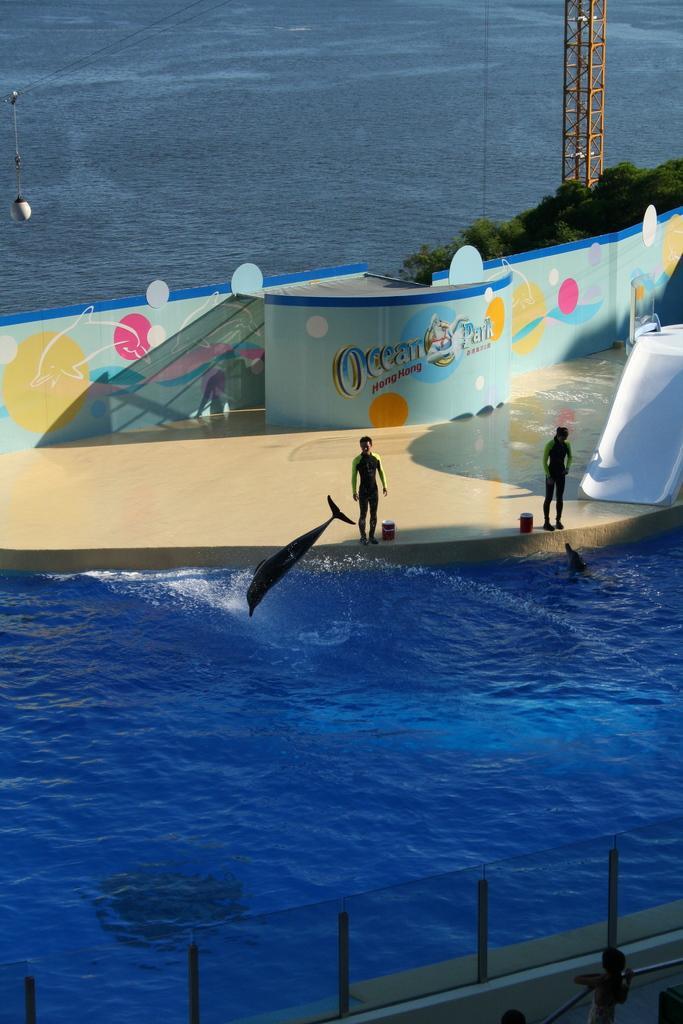How would you summarize this image in a sentence or two? In this image I can see water and a stage on it. On this stage I can see few people are standing and here I can see a fish. In the background I can see few plants and a pole. 